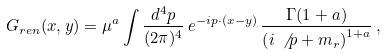<formula> <loc_0><loc_0><loc_500><loc_500>G _ { r e n } ( x , y ) = \mu ^ { a } \int \frac { d ^ { 4 } p } { ( 2 \pi ) ^ { 4 } } \, e ^ { - i p \cdot ( x - y ) } \, \frac { \Gamma ( 1 + a ) } { \left ( i \, \not \, p + m _ { r } \right ) ^ { 1 + a } } \, ,</formula> 